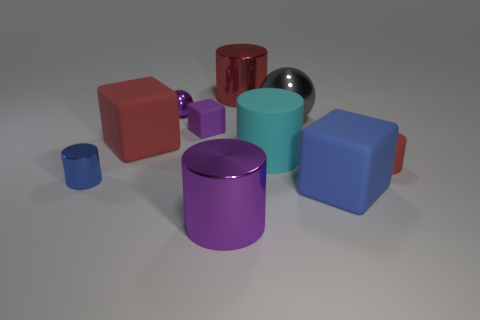Subtract all cyan cylinders. How many cylinders are left? 4 Subtract all small red cylinders. How many cylinders are left? 4 Subtract all gray cylinders. Subtract all green blocks. How many cylinders are left? 5 Subtract all balls. How many objects are left? 8 Subtract all large red cylinders. Subtract all large gray spheres. How many objects are left? 8 Add 2 large cyan cylinders. How many large cyan cylinders are left? 3 Add 8 large yellow things. How many large yellow things exist? 8 Subtract 0 brown cubes. How many objects are left? 10 